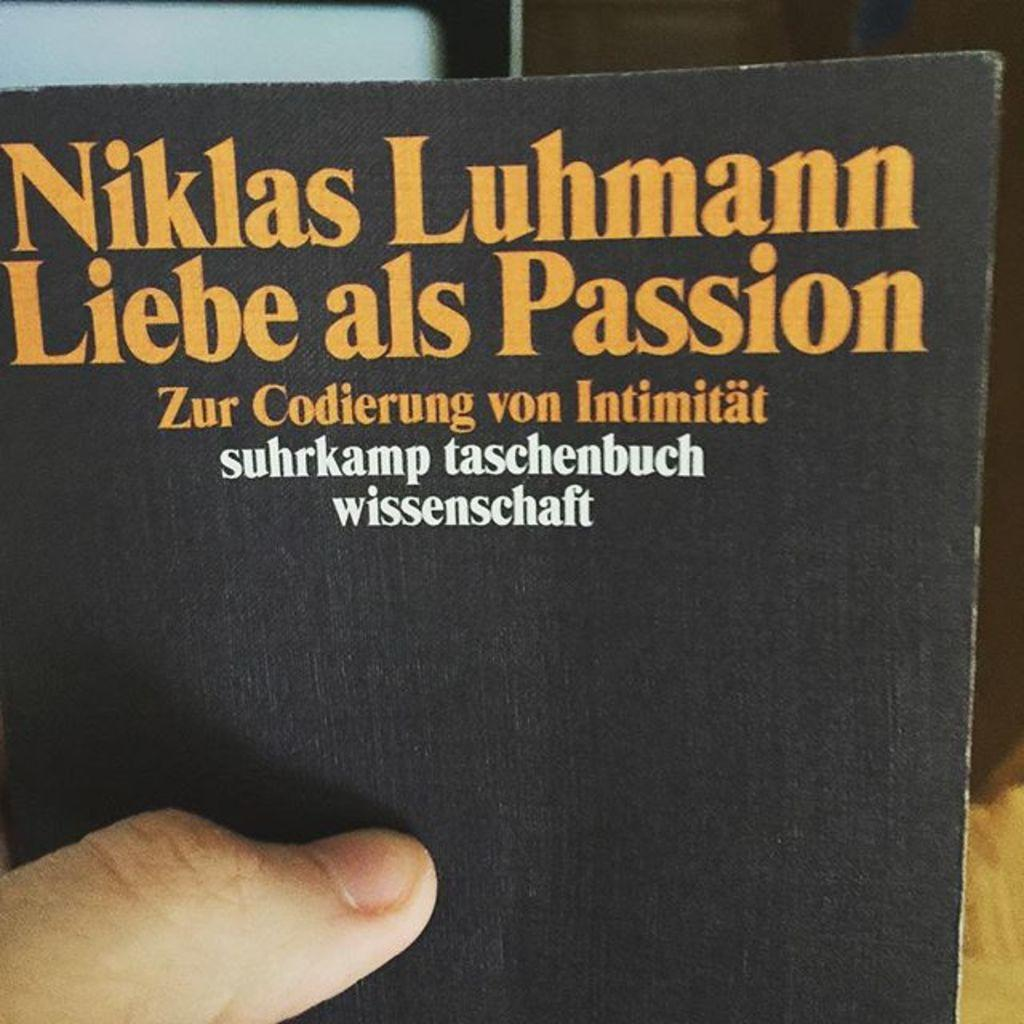<image>
Render a clear and concise summary of the photo. A black book with yellow letters that read, "Niklas Luhmann Liebe als Passion." 